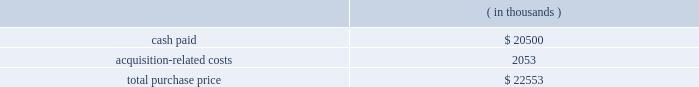Note 3 .
Business combinations purchase combinations .
During the fiscal years presented , the company made a number of purchase acquisitions .
For each acquisition , the excess of the purchase price over the estimated value of the net tangible assets acquired was allocated to various intangible assets , consisting primarily of developed technology , customer and contract-related assets and goodwill .
The values assigned to developed technologies related to each acquisition were based upon future discounted cash flows related to the existing products 2019 projected income streams .
Goodwill , representing the excess of the purchase consideration over the fair value of tangible and identifiable intangible assets acquired in the acquisitions , will not to be amortized .
Goodwill is not deductible for tax purposes .
The amounts allocated to purchased in-process research and developments were determined through established valuation techniques in the high-technology industry and were expensed upon acquisition because technological feasibility had not been established and no future alternative uses existed .
The consolidated financial statements include the operating results of each business from the date of acquisition .
The company does not consider these acquisitions to be material to its results of operations and is therefore not presenting pro forma statements of operations for the fiscal years ended october 31 , 2006 , 2005 and 2004 .
Fiscal 2006 acquisitions sigma-c software ag ( sigma-c ) the company acquired sigma-c on august 16 , 2006 in an all-cash transaction .
Reasons for the acquisition .
Sigma-c provides simulation software that allows semiconductor manufacturers and their suppliers to develop and optimize process sequences for optical lithography , e-beam lithography and next-generation lithography technologies .
The company believes the acquisition will enable a tighter integration between design and manufacturing tools , allowing the company 2019s customers to perform more accurate design layout analysis with 3d lithography simulation and better understand issues that affect ic wafer yields .
Purchase price .
The company paid $ 20.5 million in cash for the outstanding shares and shareholder notes of which $ 2.05 million was deposited with an escrow agent and will be paid per the escrow agreement .
The company believes that the escrow amount will be paid .
The total purchase consideration consisted of: .
Acquisition-related costs of $ 2.1 million consist primarily of legal , tax and accounting fees , estimated facilities closure costs and employee termination costs .
As of october 31 , 2006 , the company had paid $ 0.9 million of the acquisition-related costs .
The $ 1.2 million balance remaining at october 31 , 2006 primarily consists of legal , tax and accounting fees , estimated facilities closure costs and employee termination costs .
Assets acquired .
The company performed a preliminary valuation and allocated the total purchase consideration to assets and liabilities .
The company acquired $ 6.0 million of intangible assets consisting of $ 3.9 million in existing technology , $ 1.9 million in customer relationships and $ 0.2 million in trade names to be amortized over five years .
The company also acquired assets of $ 3.9 million and assumed liabilities of $ 5.1 million as result of this transaction .
Goodwill , representing the excess of the purchase price over the .
What percentage of the total purchase price was intangible assets? 
Computations: ((6 * 1000) / 22553)
Answer: 0.26604. Note 3 .
Business combinations purchase combinations .
During the fiscal years presented , the company made a number of purchase acquisitions .
For each acquisition , the excess of the purchase price over the estimated value of the net tangible assets acquired was allocated to various intangible assets , consisting primarily of developed technology , customer and contract-related assets and goodwill .
The values assigned to developed technologies related to each acquisition were based upon future discounted cash flows related to the existing products 2019 projected income streams .
Goodwill , representing the excess of the purchase consideration over the fair value of tangible and identifiable intangible assets acquired in the acquisitions , will not to be amortized .
Goodwill is not deductible for tax purposes .
The amounts allocated to purchased in-process research and developments were determined through established valuation techniques in the high-technology industry and were expensed upon acquisition because technological feasibility had not been established and no future alternative uses existed .
The consolidated financial statements include the operating results of each business from the date of acquisition .
The company does not consider these acquisitions to be material to its results of operations and is therefore not presenting pro forma statements of operations for the fiscal years ended october 31 , 2006 , 2005 and 2004 .
Fiscal 2006 acquisitions sigma-c software ag ( sigma-c ) the company acquired sigma-c on august 16 , 2006 in an all-cash transaction .
Reasons for the acquisition .
Sigma-c provides simulation software that allows semiconductor manufacturers and their suppliers to develop and optimize process sequences for optical lithography , e-beam lithography and next-generation lithography technologies .
The company believes the acquisition will enable a tighter integration between design and manufacturing tools , allowing the company 2019s customers to perform more accurate design layout analysis with 3d lithography simulation and better understand issues that affect ic wafer yields .
Purchase price .
The company paid $ 20.5 million in cash for the outstanding shares and shareholder notes of which $ 2.05 million was deposited with an escrow agent and will be paid per the escrow agreement .
The company believes that the escrow amount will be paid .
The total purchase consideration consisted of: .
Acquisition-related costs of $ 2.1 million consist primarily of legal , tax and accounting fees , estimated facilities closure costs and employee termination costs .
As of october 31 , 2006 , the company had paid $ 0.9 million of the acquisition-related costs .
The $ 1.2 million balance remaining at october 31 , 2006 primarily consists of legal , tax and accounting fees , estimated facilities closure costs and employee termination costs .
Assets acquired .
The company performed a preliminary valuation and allocated the total purchase consideration to assets and liabilities .
The company acquired $ 6.0 million of intangible assets consisting of $ 3.9 million in existing technology , $ 1.9 million in customer relationships and $ 0.2 million in trade names to be amortized over five years .
The company also acquired assets of $ 3.9 million and assumed liabilities of $ 5.1 million as result of this transaction .
Goodwill , representing the excess of the purchase price over the .
What is the percentage of existing technology among the total intangible assets? 
Rationale: it is the value of the existing technology divided by the total value of intangible assets , then turned into a percentage .
Computations: (3.9 / 6.0)
Answer: 0.65. 